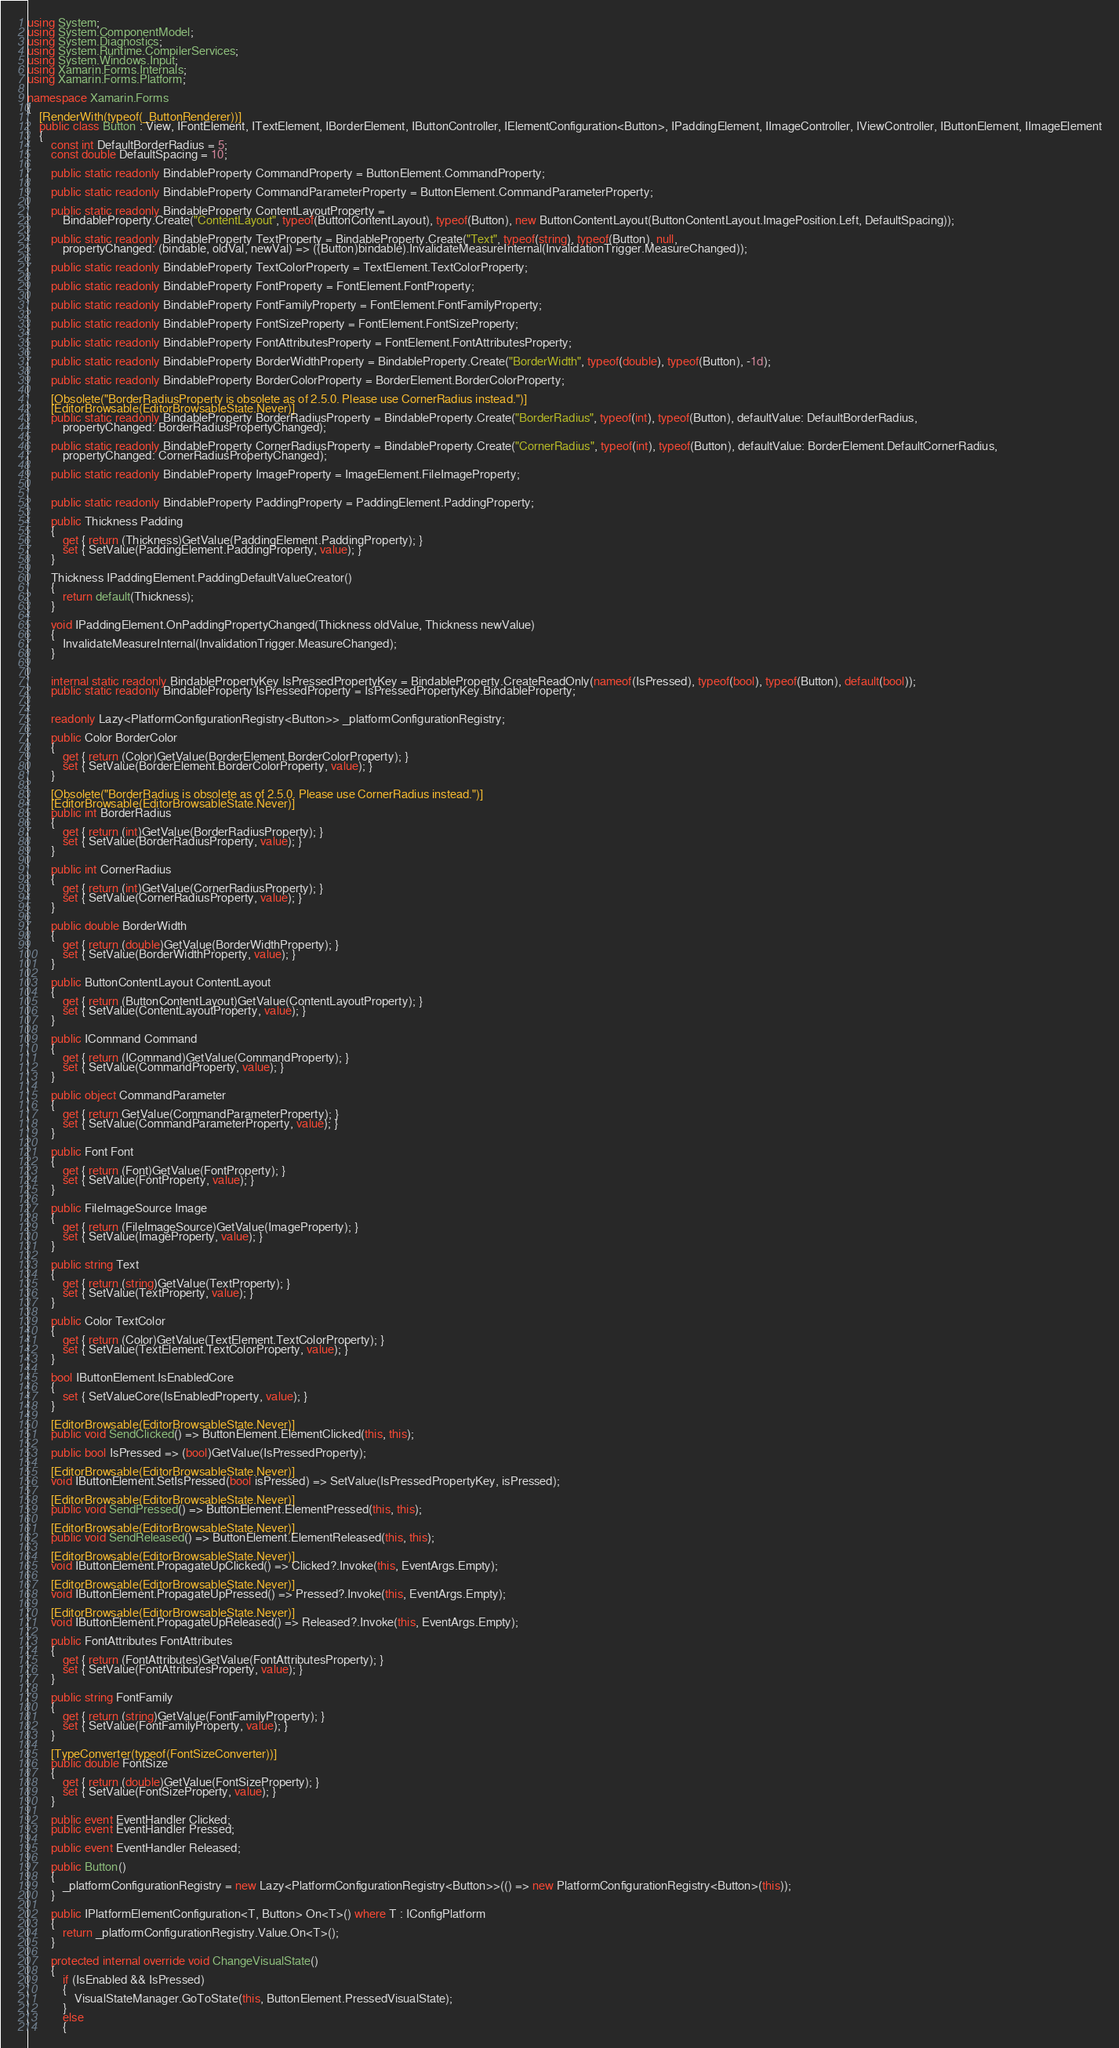<code> <loc_0><loc_0><loc_500><loc_500><_C#_>using System;
using System.ComponentModel;
using System.Diagnostics;
using System.Runtime.CompilerServices;
using System.Windows.Input;
using Xamarin.Forms.Internals;
using Xamarin.Forms.Platform;

namespace Xamarin.Forms
{
	[RenderWith(typeof(_ButtonRenderer))]
	public class Button : View, IFontElement, ITextElement, IBorderElement, IButtonController, IElementConfiguration<Button>, IPaddingElement, IImageController, IViewController, IButtonElement, IImageElement
	{
		const int DefaultBorderRadius = 5;
		const double DefaultSpacing = 10;

		public static readonly BindableProperty CommandProperty = ButtonElement.CommandProperty;

		public static readonly BindableProperty CommandParameterProperty = ButtonElement.CommandParameterProperty;

		public static readonly BindableProperty ContentLayoutProperty =
			BindableProperty.Create("ContentLayout", typeof(ButtonContentLayout), typeof(Button), new ButtonContentLayout(ButtonContentLayout.ImagePosition.Left, DefaultSpacing));

		public static readonly BindableProperty TextProperty = BindableProperty.Create("Text", typeof(string), typeof(Button), null,
			propertyChanged: (bindable, oldVal, newVal) => ((Button)bindable).InvalidateMeasureInternal(InvalidationTrigger.MeasureChanged));

		public static readonly BindableProperty TextColorProperty = TextElement.TextColorProperty;

		public static readonly BindableProperty FontProperty = FontElement.FontProperty;

		public static readonly BindableProperty FontFamilyProperty = FontElement.FontFamilyProperty;

		public static readonly BindableProperty FontSizeProperty = FontElement.FontSizeProperty;

		public static readonly BindableProperty FontAttributesProperty = FontElement.FontAttributesProperty;

		public static readonly BindableProperty BorderWidthProperty = BindableProperty.Create("BorderWidth", typeof(double), typeof(Button), -1d);

		public static readonly BindableProperty BorderColorProperty = BorderElement.BorderColorProperty;

		[Obsolete("BorderRadiusProperty is obsolete as of 2.5.0. Please use CornerRadius instead.")]
		[EditorBrowsable(EditorBrowsableState.Never)]
		public static readonly BindableProperty BorderRadiusProperty = BindableProperty.Create("BorderRadius", typeof(int), typeof(Button), defaultValue: DefaultBorderRadius,
			propertyChanged: BorderRadiusPropertyChanged);

		public static readonly BindableProperty CornerRadiusProperty = BindableProperty.Create("CornerRadius", typeof(int), typeof(Button), defaultValue: BorderElement.DefaultCornerRadius,
			propertyChanged: CornerRadiusPropertyChanged);

		public static readonly BindableProperty ImageProperty = ImageElement.FileImageProperty;


		public static readonly BindableProperty PaddingProperty = PaddingElement.PaddingProperty;

		public Thickness Padding
		{
			get { return (Thickness)GetValue(PaddingElement.PaddingProperty); }
			set { SetValue(PaddingElement.PaddingProperty, value); }
		}

		Thickness IPaddingElement.PaddingDefaultValueCreator()
		{
			return default(Thickness);
		}

		void IPaddingElement.OnPaddingPropertyChanged(Thickness oldValue, Thickness newValue)
		{
			InvalidateMeasureInternal(InvalidationTrigger.MeasureChanged);
		}


		internal static readonly BindablePropertyKey IsPressedPropertyKey = BindableProperty.CreateReadOnly(nameof(IsPressed), typeof(bool), typeof(Button), default(bool));
		public static readonly BindableProperty IsPressedProperty = IsPressedPropertyKey.BindableProperty;


		readonly Lazy<PlatformConfigurationRegistry<Button>> _platformConfigurationRegistry;

		public Color BorderColor
		{
			get { return (Color)GetValue(BorderElement.BorderColorProperty); }
			set { SetValue(BorderElement.BorderColorProperty, value); }
		}

		[Obsolete("BorderRadius is obsolete as of 2.5.0. Please use CornerRadius instead.")]
		[EditorBrowsable(EditorBrowsableState.Never)]
		public int BorderRadius
		{
			get { return (int)GetValue(BorderRadiusProperty); }
			set { SetValue(BorderRadiusProperty, value); }
		}

		public int CornerRadius
		{
			get { return (int)GetValue(CornerRadiusProperty); }
			set { SetValue(CornerRadiusProperty, value); }
		}

		public double BorderWidth
		{
			get { return (double)GetValue(BorderWidthProperty); }
			set { SetValue(BorderWidthProperty, value); }
		}

		public ButtonContentLayout ContentLayout
		{
			get { return (ButtonContentLayout)GetValue(ContentLayoutProperty); }
			set { SetValue(ContentLayoutProperty, value); }
		}

		public ICommand Command
		{
			get { return (ICommand)GetValue(CommandProperty); }
			set { SetValue(CommandProperty, value); }
		}

		public object CommandParameter
		{
			get { return GetValue(CommandParameterProperty); }
			set { SetValue(CommandParameterProperty, value); }
		}

		public Font Font
		{
			get { return (Font)GetValue(FontProperty); }
			set { SetValue(FontProperty, value); }
		}

		public FileImageSource Image
		{
			get { return (FileImageSource)GetValue(ImageProperty); }
			set { SetValue(ImageProperty, value); }
		}

		public string Text
		{
			get { return (string)GetValue(TextProperty); }
			set { SetValue(TextProperty, value); }
		}

		public Color TextColor
		{
			get { return (Color)GetValue(TextElement.TextColorProperty); }
			set { SetValue(TextElement.TextColorProperty, value); }
		}

		bool IButtonElement.IsEnabledCore
		{
			set { SetValueCore(IsEnabledProperty, value); }
		}

		[EditorBrowsable(EditorBrowsableState.Never)]
		public void SendClicked() => ButtonElement.ElementClicked(this, this);

		public bool IsPressed => (bool)GetValue(IsPressedProperty);

		[EditorBrowsable(EditorBrowsableState.Never)]
		void IButtonElement.SetIsPressed(bool isPressed) => SetValue(IsPressedPropertyKey, isPressed);

		[EditorBrowsable(EditorBrowsableState.Never)]
		public void SendPressed() => ButtonElement.ElementPressed(this, this);

		[EditorBrowsable(EditorBrowsableState.Never)]
		public void SendReleased() => ButtonElement.ElementReleased(this, this);

		[EditorBrowsable(EditorBrowsableState.Never)]
		void IButtonElement.PropagateUpClicked() => Clicked?.Invoke(this, EventArgs.Empty);

		[EditorBrowsable(EditorBrowsableState.Never)]
		void IButtonElement.PropagateUpPressed() => Pressed?.Invoke(this, EventArgs.Empty);

		[EditorBrowsable(EditorBrowsableState.Never)]
		void IButtonElement.PropagateUpReleased() => Released?.Invoke(this, EventArgs.Empty);

		public FontAttributes FontAttributes
		{
			get { return (FontAttributes)GetValue(FontAttributesProperty); }
			set { SetValue(FontAttributesProperty, value); }
		}

		public string FontFamily
		{
			get { return (string)GetValue(FontFamilyProperty); }
			set { SetValue(FontFamilyProperty, value); }
		}

		[TypeConverter(typeof(FontSizeConverter))]
		public double FontSize
		{
			get { return (double)GetValue(FontSizeProperty); }
			set { SetValue(FontSizeProperty, value); }
		}

		public event EventHandler Clicked;
		public event EventHandler Pressed;

		public event EventHandler Released;

		public Button()
		{
			_platformConfigurationRegistry = new Lazy<PlatformConfigurationRegistry<Button>>(() => new PlatformConfigurationRegistry<Button>(this));
		}

		public IPlatformElementConfiguration<T, Button> On<T>() where T : IConfigPlatform
		{
			return _platformConfigurationRegistry.Value.On<T>();
		}

		protected internal override void ChangeVisualState()
		{
			if (IsEnabled && IsPressed)
			{
				VisualStateManager.GoToState(this, ButtonElement.PressedVisualState);
			}
			else
			{</code> 